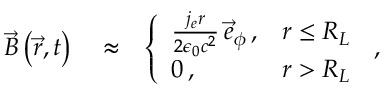Convert formula to latex. <formula><loc_0><loc_0><loc_500><loc_500>\begin{array} { r l r } { \vec { B } \left ( \vec { r } , t \right ) } & \approx } & { \left \{ \begin{array} { l l } { \frac { j _ { e } r } { 2 \epsilon _ { 0 } c ^ { 2 } } \, \vec { e } _ { \phi } \, , } & { r \leq R _ { L } } \\ { 0 \, , } & { r > R _ { L } } \end{array} \, , } \end{array}</formula> 